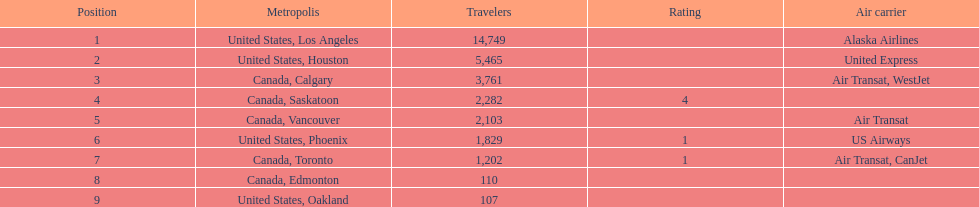How many cities from canada are on this list? 5. Could you parse the entire table? {'header': ['Position', 'Metropolis', 'Travelers', 'Rating', 'Air carrier'], 'rows': [['1', 'United States, Los Angeles', '14,749', '', 'Alaska Airlines'], ['2', 'United States, Houston', '5,465', '', 'United Express'], ['3', 'Canada, Calgary', '3,761', '', 'Air Transat, WestJet'], ['4', 'Canada, Saskatoon', '2,282', '4', ''], ['5', 'Canada, Vancouver', '2,103', '', 'Air Transat'], ['6', 'United States, Phoenix', '1,829', '1', 'US Airways'], ['7', 'Canada, Toronto', '1,202', '1', 'Air Transat, CanJet'], ['8', 'Canada, Edmonton', '110', '', ''], ['9', 'United States, Oakland', '107', '', '']]} 